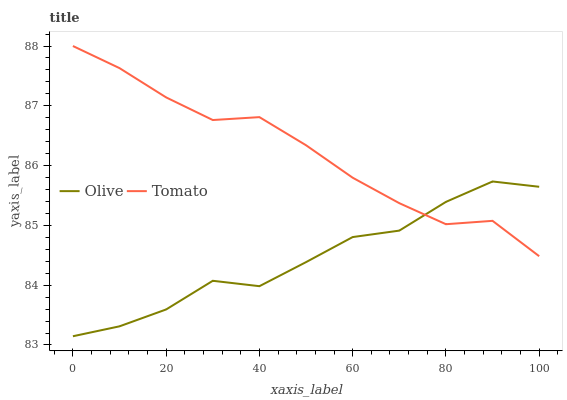Does Tomato have the minimum area under the curve?
Answer yes or no. No. Is Tomato the roughest?
Answer yes or no. No. Does Tomato have the lowest value?
Answer yes or no. No. 